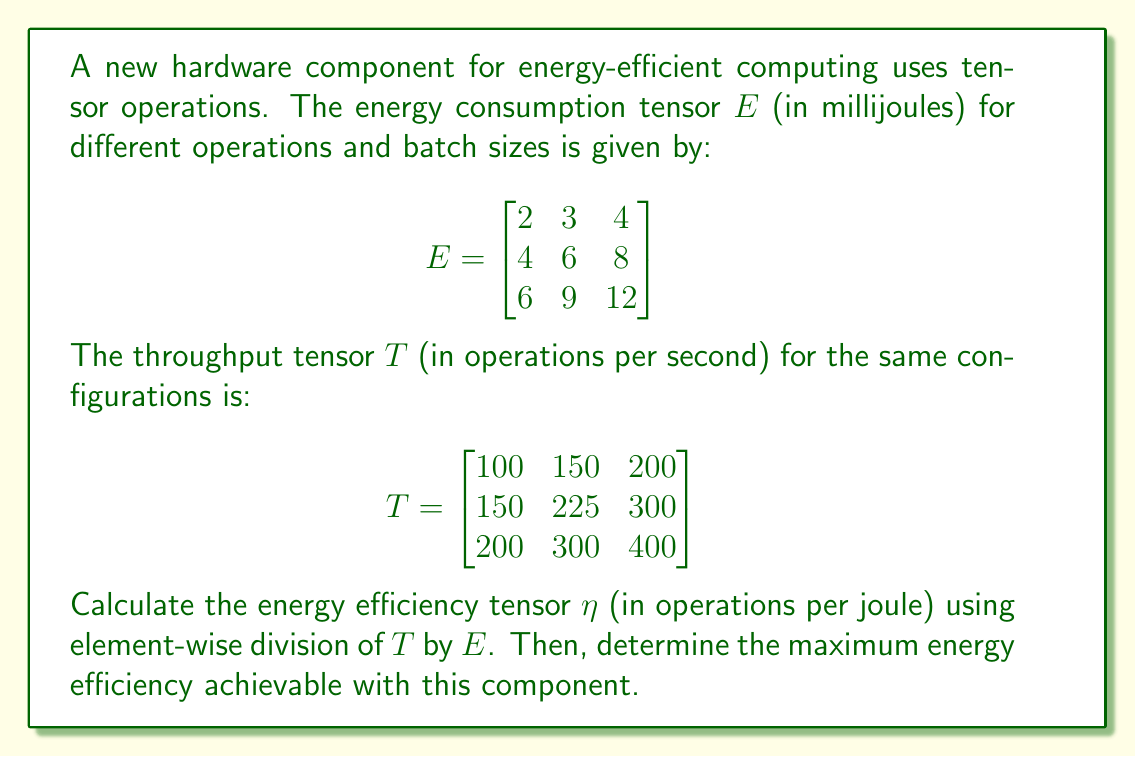Could you help me with this problem? To solve this problem, we'll follow these steps:

1) First, we need to calculate the energy efficiency tensor $\eta$ by performing element-wise division of the throughput tensor $T$ by the energy consumption tensor $E$. The formula for each element is:

   $$\eta_{ij} = \frac{T_{ij}}{E_{ij}} \times 1000$$

   We multiply by 1000 to convert from millijoules to joules.

2) Let's perform this calculation for each element:

   $$\eta_{11} = \frac{100}{2} \times 1000 = 50,000$$
   $$\eta_{12} = \frac{150}{3} \times 1000 = 50,000$$
   $$\eta_{13} = \frac{200}{4} \times 1000 = 50,000$$
   $$\eta_{21} = \frac{150}{4} \times 1000 = 37,500$$
   $$\eta_{22} = \frac{225}{6} \times 1000 = 37,500$$
   $$\eta_{23} = \frac{300}{8} \times 1000 = 37,500$$
   $$\eta_{31} = \frac{200}{6} \times 1000 = 33,333.33$$
   $$\eta_{32} = \frac{300}{9} \times 1000 = 33,333.33$$
   $$\eta_{33} = \frac{400}{12} \times 1000 = 33,333.33$$

3) Now we can write the energy efficiency tensor:

   $$\eta = \begin{bmatrix}
   50,000 & 50,000 & 50,000 \\
   37,500 & 37,500 & 37,500 \\
   33,333.33 & 33,333.33 & 33,333.33
   \end{bmatrix}$$

4) To find the maximum energy efficiency, we need to identify the largest value in this tensor.

5) The largest value in the $\eta$ tensor is 50,000 operations per joule, which appears in the entire first row.

Therefore, the maximum energy efficiency achievable with this component is 50,000 operations per joule.
Answer: 50,000 operations per joule 